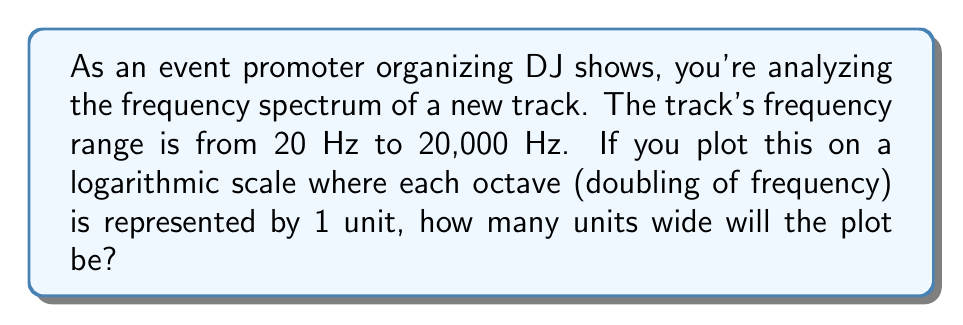Give your solution to this math problem. To solve this problem, we need to understand logarithmic scales and octaves:

1) An octave is a doubling of frequency. On a logarithmic scale, each octave is represented by an equal distance.

2) We can use the logarithm base 2 to determine how many octaves are between two frequencies:

   $$ \text{Number of octaves} = \log_2(\frac{f_2}{f_1}) $$

   Where $f_2$ is the higher frequency and $f_1$ is the lower frequency.

3) Let's plug in our values:

   $$ \text{Number of octaves} = \log_2(\frac{20,000 \text{ Hz}}{20 \text{ Hz}}) $$

4) Simplify:

   $$ \text{Number of octaves} = \log_2(1000) $$

5) To solve this, we can use the change of base formula:

   $$ \log_2(1000) = \frac{\log(1000)}{\log(2)} $$

6) Calculate:

   $$ \frac{\log(1000)}{\log(2)} \approx 9.97 $$

Therefore, the plot will be approximately 9.97 units wide on the logarithmic scale.
Answer: 9.97 units 